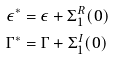<formula> <loc_0><loc_0><loc_500><loc_500>\epsilon ^ { * } & = \epsilon + \Sigma _ { 1 } ^ { R } ( 0 ) \\ \Gamma ^ { * } & = \Gamma + \Sigma _ { 1 } ^ { I } ( 0 )</formula> 